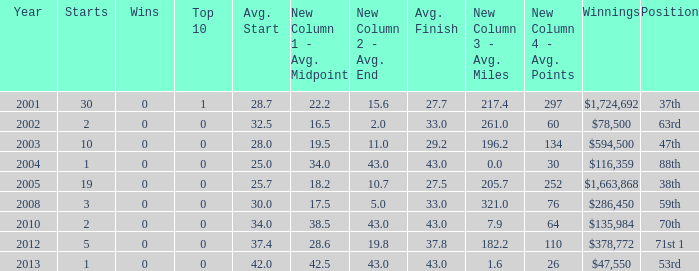What is the average top 10 score for 2 starts, winnings of $135,984 and an average finish more than 43? None. 